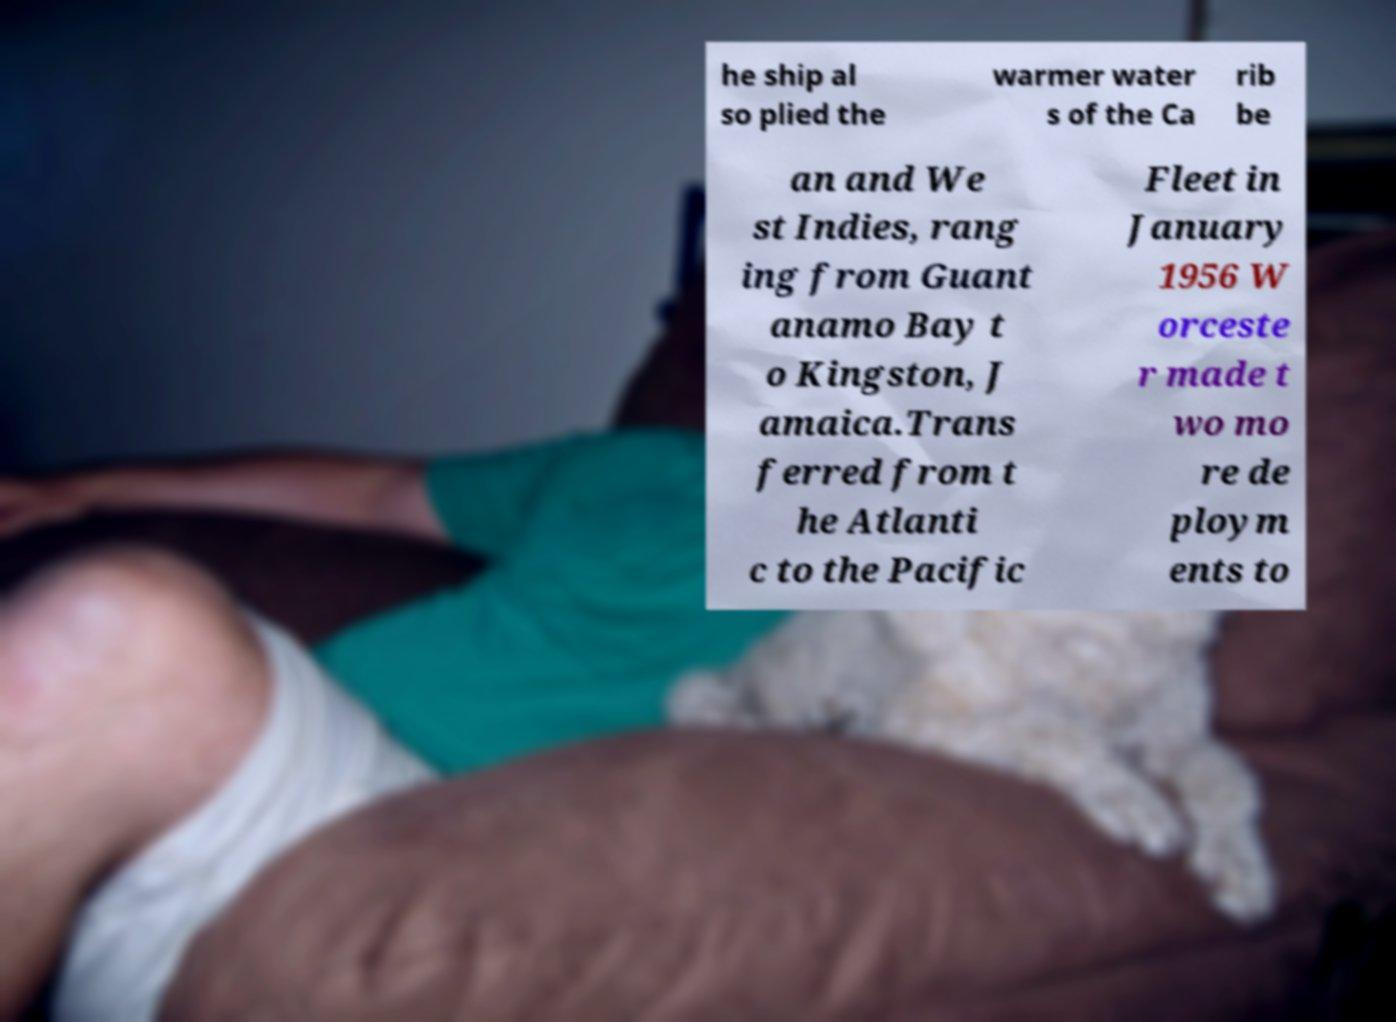For documentation purposes, I need the text within this image transcribed. Could you provide that? he ship al so plied the warmer water s of the Ca rib be an and We st Indies, rang ing from Guant anamo Bay t o Kingston, J amaica.Trans ferred from t he Atlanti c to the Pacific Fleet in January 1956 W orceste r made t wo mo re de ploym ents to 